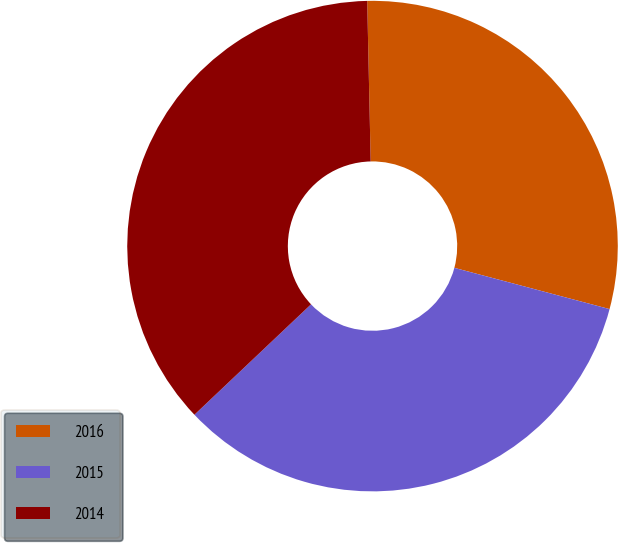Convert chart. <chart><loc_0><loc_0><loc_500><loc_500><pie_chart><fcel>2016<fcel>2015<fcel>2014<nl><fcel>29.48%<fcel>33.8%<fcel>36.72%<nl></chart> 